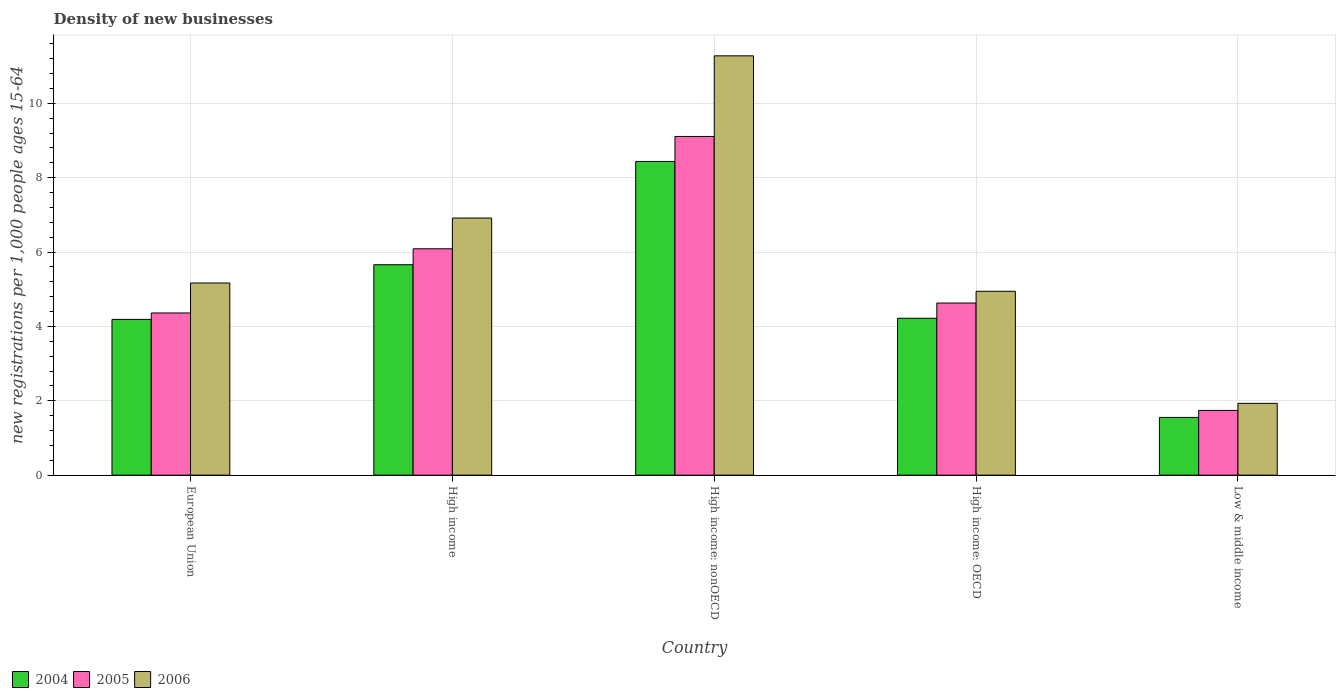How many different coloured bars are there?
Provide a succinct answer. 3. Are the number of bars per tick equal to the number of legend labels?
Provide a succinct answer. Yes. Are the number of bars on each tick of the X-axis equal?
Provide a succinct answer. Yes. How many bars are there on the 4th tick from the right?
Offer a terse response. 3. What is the label of the 5th group of bars from the left?
Ensure brevity in your answer.  Low & middle income. In how many cases, is the number of bars for a given country not equal to the number of legend labels?
Make the answer very short. 0. What is the number of new registrations in 2004 in European Union?
Keep it short and to the point. 4.19. Across all countries, what is the maximum number of new registrations in 2006?
Provide a short and direct response. 11.28. Across all countries, what is the minimum number of new registrations in 2005?
Provide a short and direct response. 1.74. In which country was the number of new registrations in 2004 maximum?
Your response must be concise. High income: nonOECD. In which country was the number of new registrations in 2005 minimum?
Offer a very short reply. Low & middle income. What is the total number of new registrations in 2004 in the graph?
Offer a terse response. 24.06. What is the difference between the number of new registrations in 2006 in High income: OECD and that in Low & middle income?
Provide a succinct answer. 3.01. What is the difference between the number of new registrations in 2006 in High income and the number of new registrations in 2005 in European Union?
Keep it short and to the point. 2.55. What is the average number of new registrations in 2006 per country?
Keep it short and to the point. 6.05. What is the difference between the number of new registrations of/in 2004 and number of new registrations of/in 2005 in European Union?
Your answer should be compact. -0.17. What is the ratio of the number of new registrations in 2004 in European Union to that in High income: OECD?
Give a very brief answer. 0.99. Is the number of new registrations in 2006 in High income: nonOECD less than that in Low & middle income?
Provide a succinct answer. No. Is the difference between the number of new registrations in 2004 in High income and High income: nonOECD greater than the difference between the number of new registrations in 2005 in High income and High income: nonOECD?
Make the answer very short. Yes. What is the difference between the highest and the second highest number of new registrations in 2006?
Make the answer very short. 6.11. What is the difference between the highest and the lowest number of new registrations in 2004?
Offer a very short reply. 6.88. In how many countries, is the number of new registrations in 2006 greater than the average number of new registrations in 2006 taken over all countries?
Provide a short and direct response. 2. Is the sum of the number of new registrations in 2006 in High income and High income: nonOECD greater than the maximum number of new registrations in 2005 across all countries?
Your answer should be compact. Yes. What does the 2nd bar from the left in High income: OECD represents?
Your answer should be very brief. 2005. Does the graph contain grids?
Your response must be concise. Yes. How many legend labels are there?
Offer a very short reply. 3. What is the title of the graph?
Provide a succinct answer. Density of new businesses. What is the label or title of the Y-axis?
Your answer should be very brief. New registrations per 1,0 people ages 15-64. What is the new registrations per 1,000 people ages 15-64 of 2004 in European Union?
Give a very brief answer. 4.19. What is the new registrations per 1,000 people ages 15-64 of 2005 in European Union?
Offer a very short reply. 4.36. What is the new registrations per 1,000 people ages 15-64 in 2006 in European Union?
Your response must be concise. 5.17. What is the new registrations per 1,000 people ages 15-64 in 2004 in High income?
Your response must be concise. 5.66. What is the new registrations per 1,000 people ages 15-64 in 2005 in High income?
Provide a short and direct response. 6.09. What is the new registrations per 1,000 people ages 15-64 in 2006 in High income?
Give a very brief answer. 6.91. What is the new registrations per 1,000 people ages 15-64 in 2004 in High income: nonOECD?
Your answer should be compact. 8.44. What is the new registrations per 1,000 people ages 15-64 of 2005 in High income: nonOECD?
Offer a terse response. 9.11. What is the new registrations per 1,000 people ages 15-64 in 2006 in High income: nonOECD?
Offer a very short reply. 11.28. What is the new registrations per 1,000 people ages 15-64 of 2004 in High income: OECD?
Your answer should be compact. 4.22. What is the new registrations per 1,000 people ages 15-64 in 2005 in High income: OECD?
Keep it short and to the point. 4.63. What is the new registrations per 1,000 people ages 15-64 in 2006 in High income: OECD?
Keep it short and to the point. 4.94. What is the new registrations per 1,000 people ages 15-64 of 2004 in Low & middle income?
Give a very brief answer. 1.55. What is the new registrations per 1,000 people ages 15-64 of 2005 in Low & middle income?
Give a very brief answer. 1.74. What is the new registrations per 1,000 people ages 15-64 of 2006 in Low & middle income?
Ensure brevity in your answer.  1.93. Across all countries, what is the maximum new registrations per 1,000 people ages 15-64 in 2004?
Your response must be concise. 8.44. Across all countries, what is the maximum new registrations per 1,000 people ages 15-64 in 2005?
Provide a succinct answer. 9.11. Across all countries, what is the maximum new registrations per 1,000 people ages 15-64 of 2006?
Give a very brief answer. 11.28. Across all countries, what is the minimum new registrations per 1,000 people ages 15-64 in 2004?
Provide a short and direct response. 1.55. Across all countries, what is the minimum new registrations per 1,000 people ages 15-64 of 2005?
Provide a succinct answer. 1.74. Across all countries, what is the minimum new registrations per 1,000 people ages 15-64 in 2006?
Make the answer very short. 1.93. What is the total new registrations per 1,000 people ages 15-64 of 2004 in the graph?
Your response must be concise. 24.06. What is the total new registrations per 1,000 people ages 15-64 in 2005 in the graph?
Give a very brief answer. 25.93. What is the total new registrations per 1,000 people ages 15-64 of 2006 in the graph?
Ensure brevity in your answer.  30.23. What is the difference between the new registrations per 1,000 people ages 15-64 of 2004 in European Union and that in High income?
Your answer should be compact. -1.47. What is the difference between the new registrations per 1,000 people ages 15-64 in 2005 in European Union and that in High income?
Make the answer very short. -1.73. What is the difference between the new registrations per 1,000 people ages 15-64 of 2006 in European Union and that in High income?
Give a very brief answer. -1.75. What is the difference between the new registrations per 1,000 people ages 15-64 of 2004 in European Union and that in High income: nonOECD?
Give a very brief answer. -4.25. What is the difference between the new registrations per 1,000 people ages 15-64 of 2005 in European Union and that in High income: nonOECD?
Ensure brevity in your answer.  -4.75. What is the difference between the new registrations per 1,000 people ages 15-64 in 2006 in European Union and that in High income: nonOECD?
Offer a very short reply. -6.11. What is the difference between the new registrations per 1,000 people ages 15-64 in 2004 in European Union and that in High income: OECD?
Keep it short and to the point. -0.03. What is the difference between the new registrations per 1,000 people ages 15-64 in 2005 in European Union and that in High income: OECD?
Your answer should be very brief. -0.27. What is the difference between the new registrations per 1,000 people ages 15-64 in 2006 in European Union and that in High income: OECD?
Your answer should be compact. 0.22. What is the difference between the new registrations per 1,000 people ages 15-64 of 2004 in European Union and that in Low & middle income?
Make the answer very short. 2.64. What is the difference between the new registrations per 1,000 people ages 15-64 in 2005 in European Union and that in Low & middle income?
Offer a very short reply. 2.62. What is the difference between the new registrations per 1,000 people ages 15-64 in 2006 in European Union and that in Low & middle income?
Offer a very short reply. 3.24. What is the difference between the new registrations per 1,000 people ages 15-64 in 2004 in High income and that in High income: nonOECD?
Offer a terse response. -2.78. What is the difference between the new registrations per 1,000 people ages 15-64 in 2005 in High income and that in High income: nonOECD?
Offer a very short reply. -3.02. What is the difference between the new registrations per 1,000 people ages 15-64 of 2006 in High income and that in High income: nonOECD?
Offer a terse response. -4.36. What is the difference between the new registrations per 1,000 people ages 15-64 of 2004 in High income and that in High income: OECD?
Provide a short and direct response. 1.44. What is the difference between the new registrations per 1,000 people ages 15-64 in 2005 in High income and that in High income: OECD?
Provide a succinct answer. 1.46. What is the difference between the new registrations per 1,000 people ages 15-64 in 2006 in High income and that in High income: OECD?
Offer a terse response. 1.97. What is the difference between the new registrations per 1,000 people ages 15-64 in 2004 in High income and that in Low & middle income?
Ensure brevity in your answer.  4.11. What is the difference between the new registrations per 1,000 people ages 15-64 of 2005 in High income and that in Low & middle income?
Your answer should be compact. 4.35. What is the difference between the new registrations per 1,000 people ages 15-64 in 2006 in High income and that in Low & middle income?
Give a very brief answer. 4.98. What is the difference between the new registrations per 1,000 people ages 15-64 of 2004 in High income: nonOECD and that in High income: OECD?
Your answer should be compact. 4.22. What is the difference between the new registrations per 1,000 people ages 15-64 in 2005 in High income: nonOECD and that in High income: OECD?
Offer a very short reply. 4.48. What is the difference between the new registrations per 1,000 people ages 15-64 in 2006 in High income: nonOECD and that in High income: OECD?
Your answer should be very brief. 6.33. What is the difference between the new registrations per 1,000 people ages 15-64 in 2004 in High income: nonOECD and that in Low & middle income?
Your response must be concise. 6.88. What is the difference between the new registrations per 1,000 people ages 15-64 in 2005 in High income: nonOECD and that in Low & middle income?
Your answer should be compact. 7.37. What is the difference between the new registrations per 1,000 people ages 15-64 of 2006 in High income: nonOECD and that in Low & middle income?
Provide a succinct answer. 9.34. What is the difference between the new registrations per 1,000 people ages 15-64 in 2004 in High income: OECD and that in Low & middle income?
Make the answer very short. 2.67. What is the difference between the new registrations per 1,000 people ages 15-64 of 2005 in High income: OECD and that in Low & middle income?
Provide a short and direct response. 2.89. What is the difference between the new registrations per 1,000 people ages 15-64 of 2006 in High income: OECD and that in Low & middle income?
Your answer should be very brief. 3.01. What is the difference between the new registrations per 1,000 people ages 15-64 in 2004 in European Union and the new registrations per 1,000 people ages 15-64 in 2005 in High income?
Your response must be concise. -1.9. What is the difference between the new registrations per 1,000 people ages 15-64 of 2004 in European Union and the new registrations per 1,000 people ages 15-64 of 2006 in High income?
Give a very brief answer. -2.73. What is the difference between the new registrations per 1,000 people ages 15-64 of 2005 in European Union and the new registrations per 1,000 people ages 15-64 of 2006 in High income?
Your answer should be very brief. -2.55. What is the difference between the new registrations per 1,000 people ages 15-64 of 2004 in European Union and the new registrations per 1,000 people ages 15-64 of 2005 in High income: nonOECD?
Provide a short and direct response. -4.92. What is the difference between the new registrations per 1,000 people ages 15-64 in 2004 in European Union and the new registrations per 1,000 people ages 15-64 in 2006 in High income: nonOECD?
Offer a very short reply. -7.09. What is the difference between the new registrations per 1,000 people ages 15-64 in 2005 in European Union and the new registrations per 1,000 people ages 15-64 in 2006 in High income: nonOECD?
Your response must be concise. -6.91. What is the difference between the new registrations per 1,000 people ages 15-64 in 2004 in European Union and the new registrations per 1,000 people ages 15-64 in 2005 in High income: OECD?
Provide a short and direct response. -0.44. What is the difference between the new registrations per 1,000 people ages 15-64 in 2004 in European Union and the new registrations per 1,000 people ages 15-64 in 2006 in High income: OECD?
Keep it short and to the point. -0.76. What is the difference between the new registrations per 1,000 people ages 15-64 in 2005 in European Union and the new registrations per 1,000 people ages 15-64 in 2006 in High income: OECD?
Provide a short and direct response. -0.58. What is the difference between the new registrations per 1,000 people ages 15-64 of 2004 in European Union and the new registrations per 1,000 people ages 15-64 of 2005 in Low & middle income?
Keep it short and to the point. 2.45. What is the difference between the new registrations per 1,000 people ages 15-64 of 2004 in European Union and the new registrations per 1,000 people ages 15-64 of 2006 in Low & middle income?
Offer a terse response. 2.26. What is the difference between the new registrations per 1,000 people ages 15-64 of 2005 in European Union and the new registrations per 1,000 people ages 15-64 of 2006 in Low & middle income?
Make the answer very short. 2.43. What is the difference between the new registrations per 1,000 people ages 15-64 of 2004 in High income and the new registrations per 1,000 people ages 15-64 of 2005 in High income: nonOECD?
Provide a short and direct response. -3.45. What is the difference between the new registrations per 1,000 people ages 15-64 in 2004 in High income and the new registrations per 1,000 people ages 15-64 in 2006 in High income: nonOECD?
Keep it short and to the point. -5.62. What is the difference between the new registrations per 1,000 people ages 15-64 of 2005 in High income and the new registrations per 1,000 people ages 15-64 of 2006 in High income: nonOECD?
Ensure brevity in your answer.  -5.19. What is the difference between the new registrations per 1,000 people ages 15-64 of 2004 in High income and the new registrations per 1,000 people ages 15-64 of 2005 in High income: OECD?
Provide a short and direct response. 1.03. What is the difference between the new registrations per 1,000 people ages 15-64 in 2004 in High income and the new registrations per 1,000 people ages 15-64 in 2006 in High income: OECD?
Your response must be concise. 0.71. What is the difference between the new registrations per 1,000 people ages 15-64 in 2005 in High income and the new registrations per 1,000 people ages 15-64 in 2006 in High income: OECD?
Provide a short and direct response. 1.14. What is the difference between the new registrations per 1,000 people ages 15-64 of 2004 in High income and the new registrations per 1,000 people ages 15-64 of 2005 in Low & middle income?
Your answer should be compact. 3.92. What is the difference between the new registrations per 1,000 people ages 15-64 of 2004 in High income and the new registrations per 1,000 people ages 15-64 of 2006 in Low & middle income?
Ensure brevity in your answer.  3.73. What is the difference between the new registrations per 1,000 people ages 15-64 in 2005 in High income and the new registrations per 1,000 people ages 15-64 in 2006 in Low & middle income?
Provide a short and direct response. 4.16. What is the difference between the new registrations per 1,000 people ages 15-64 of 2004 in High income: nonOECD and the new registrations per 1,000 people ages 15-64 of 2005 in High income: OECD?
Provide a short and direct response. 3.81. What is the difference between the new registrations per 1,000 people ages 15-64 of 2004 in High income: nonOECD and the new registrations per 1,000 people ages 15-64 of 2006 in High income: OECD?
Your answer should be compact. 3.49. What is the difference between the new registrations per 1,000 people ages 15-64 of 2005 in High income: nonOECD and the new registrations per 1,000 people ages 15-64 of 2006 in High income: OECD?
Your answer should be compact. 4.16. What is the difference between the new registrations per 1,000 people ages 15-64 of 2004 in High income: nonOECD and the new registrations per 1,000 people ages 15-64 of 2005 in Low & middle income?
Keep it short and to the point. 6.69. What is the difference between the new registrations per 1,000 people ages 15-64 in 2004 in High income: nonOECD and the new registrations per 1,000 people ages 15-64 in 2006 in Low & middle income?
Your response must be concise. 6.5. What is the difference between the new registrations per 1,000 people ages 15-64 in 2005 in High income: nonOECD and the new registrations per 1,000 people ages 15-64 in 2006 in Low & middle income?
Ensure brevity in your answer.  7.18. What is the difference between the new registrations per 1,000 people ages 15-64 of 2004 in High income: OECD and the new registrations per 1,000 people ages 15-64 of 2005 in Low & middle income?
Keep it short and to the point. 2.48. What is the difference between the new registrations per 1,000 people ages 15-64 in 2004 in High income: OECD and the new registrations per 1,000 people ages 15-64 in 2006 in Low & middle income?
Make the answer very short. 2.29. What is the difference between the new registrations per 1,000 people ages 15-64 of 2005 in High income: OECD and the new registrations per 1,000 people ages 15-64 of 2006 in Low & middle income?
Ensure brevity in your answer.  2.7. What is the average new registrations per 1,000 people ages 15-64 of 2004 per country?
Offer a terse response. 4.81. What is the average new registrations per 1,000 people ages 15-64 of 2005 per country?
Your answer should be very brief. 5.19. What is the average new registrations per 1,000 people ages 15-64 of 2006 per country?
Offer a terse response. 6.05. What is the difference between the new registrations per 1,000 people ages 15-64 of 2004 and new registrations per 1,000 people ages 15-64 of 2005 in European Union?
Make the answer very short. -0.17. What is the difference between the new registrations per 1,000 people ages 15-64 of 2004 and new registrations per 1,000 people ages 15-64 of 2006 in European Union?
Keep it short and to the point. -0.98. What is the difference between the new registrations per 1,000 people ages 15-64 of 2005 and new registrations per 1,000 people ages 15-64 of 2006 in European Union?
Provide a short and direct response. -0.81. What is the difference between the new registrations per 1,000 people ages 15-64 of 2004 and new registrations per 1,000 people ages 15-64 of 2005 in High income?
Provide a succinct answer. -0.43. What is the difference between the new registrations per 1,000 people ages 15-64 of 2004 and new registrations per 1,000 people ages 15-64 of 2006 in High income?
Provide a short and direct response. -1.26. What is the difference between the new registrations per 1,000 people ages 15-64 in 2005 and new registrations per 1,000 people ages 15-64 in 2006 in High income?
Offer a very short reply. -0.83. What is the difference between the new registrations per 1,000 people ages 15-64 in 2004 and new registrations per 1,000 people ages 15-64 in 2005 in High income: nonOECD?
Offer a very short reply. -0.67. What is the difference between the new registrations per 1,000 people ages 15-64 of 2004 and new registrations per 1,000 people ages 15-64 of 2006 in High income: nonOECD?
Your answer should be very brief. -2.84. What is the difference between the new registrations per 1,000 people ages 15-64 of 2005 and new registrations per 1,000 people ages 15-64 of 2006 in High income: nonOECD?
Ensure brevity in your answer.  -2.17. What is the difference between the new registrations per 1,000 people ages 15-64 of 2004 and new registrations per 1,000 people ages 15-64 of 2005 in High income: OECD?
Provide a succinct answer. -0.41. What is the difference between the new registrations per 1,000 people ages 15-64 of 2004 and new registrations per 1,000 people ages 15-64 of 2006 in High income: OECD?
Keep it short and to the point. -0.73. What is the difference between the new registrations per 1,000 people ages 15-64 in 2005 and new registrations per 1,000 people ages 15-64 in 2006 in High income: OECD?
Provide a short and direct response. -0.32. What is the difference between the new registrations per 1,000 people ages 15-64 of 2004 and new registrations per 1,000 people ages 15-64 of 2005 in Low & middle income?
Give a very brief answer. -0.19. What is the difference between the new registrations per 1,000 people ages 15-64 of 2004 and new registrations per 1,000 people ages 15-64 of 2006 in Low & middle income?
Your response must be concise. -0.38. What is the difference between the new registrations per 1,000 people ages 15-64 of 2005 and new registrations per 1,000 people ages 15-64 of 2006 in Low & middle income?
Keep it short and to the point. -0.19. What is the ratio of the new registrations per 1,000 people ages 15-64 in 2004 in European Union to that in High income?
Give a very brief answer. 0.74. What is the ratio of the new registrations per 1,000 people ages 15-64 of 2005 in European Union to that in High income?
Ensure brevity in your answer.  0.72. What is the ratio of the new registrations per 1,000 people ages 15-64 of 2006 in European Union to that in High income?
Offer a very short reply. 0.75. What is the ratio of the new registrations per 1,000 people ages 15-64 of 2004 in European Union to that in High income: nonOECD?
Make the answer very short. 0.5. What is the ratio of the new registrations per 1,000 people ages 15-64 in 2005 in European Union to that in High income: nonOECD?
Your answer should be very brief. 0.48. What is the ratio of the new registrations per 1,000 people ages 15-64 in 2006 in European Union to that in High income: nonOECD?
Ensure brevity in your answer.  0.46. What is the ratio of the new registrations per 1,000 people ages 15-64 of 2005 in European Union to that in High income: OECD?
Your answer should be very brief. 0.94. What is the ratio of the new registrations per 1,000 people ages 15-64 of 2006 in European Union to that in High income: OECD?
Your answer should be compact. 1.04. What is the ratio of the new registrations per 1,000 people ages 15-64 in 2004 in European Union to that in Low & middle income?
Provide a succinct answer. 2.7. What is the ratio of the new registrations per 1,000 people ages 15-64 of 2005 in European Union to that in Low & middle income?
Provide a succinct answer. 2.51. What is the ratio of the new registrations per 1,000 people ages 15-64 of 2006 in European Union to that in Low & middle income?
Keep it short and to the point. 2.68. What is the ratio of the new registrations per 1,000 people ages 15-64 in 2004 in High income to that in High income: nonOECD?
Ensure brevity in your answer.  0.67. What is the ratio of the new registrations per 1,000 people ages 15-64 in 2005 in High income to that in High income: nonOECD?
Your answer should be very brief. 0.67. What is the ratio of the new registrations per 1,000 people ages 15-64 in 2006 in High income to that in High income: nonOECD?
Your answer should be very brief. 0.61. What is the ratio of the new registrations per 1,000 people ages 15-64 in 2004 in High income to that in High income: OECD?
Offer a very short reply. 1.34. What is the ratio of the new registrations per 1,000 people ages 15-64 in 2005 in High income to that in High income: OECD?
Provide a succinct answer. 1.31. What is the ratio of the new registrations per 1,000 people ages 15-64 in 2006 in High income to that in High income: OECD?
Make the answer very short. 1.4. What is the ratio of the new registrations per 1,000 people ages 15-64 of 2004 in High income to that in Low & middle income?
Ensure brevity in your answer.  3.64. What is the ratio of the new registrations per 1,000 people ages 15-64 of 2005 in High income to that in Low & middle income?
Keep it short and to the point. 3.5. What is the ratio of the new registrations per 1,000 people ages 15-64 of 2006 in High income to that in Low & middle income?
Offer a very short reply. 3.58. What is the ratio of the new registrations per 1,000 people ages 15-64 of 2004 in High income: nonOECD to that in High income: OECD?
Offer a terse response. 2. What is the ratio of the new registrations per 1,000 people ages 15-64 in 2005 in High income: nonOECD to that in High income: OECD?
Keep it short and to the point. 1.97. What is the ratio of the new registrations per 1,000 people ages 15-64 of 2006 in High income: nonOECD to that in High income: OECD?
Ensure brevity in your answer.  2.28. What is the ratio of the new registrations per 1,000 people ages 15-64 in 2004 in High income: nonOECD to that in Low & middle income?
Make the answer very short. 5.43. What is the ratio of the new registrations per 1,000 people ages 15-64 of 2005 in High income: nonOECD to that in Low & middle income?
Offer a very short reply. 5.23. What is the ratio of the new registrations per 1,000 people ages 15-64 of 2006 in High income: nonOECD to that in Low & middle income?
Give a very brief answer. 5.84. What is the ratio of the new registrations per 1,000 people ages 15-64 in 2004 in High income: OECD to that in Low & middle income?
Your answer should be compact. 2.72. What is the ratio of the new registrations per 1,000 people ages 15-64 in 2005 in High income: OECD to that in Low & middle income?
Provide a succinct answer. 2.66. What is the ratio of the new registrations per 1,000 people ages 15-64 of 2006 in High income: OECD to that in Low & middle income?
Offer a very short reply. 2.56. What is the difference between the highest and the second highest new registrations per 1,000 people ages 15-64 of 2004?
Offer a terse response. 2.78. What is the difference between the highest and the second highest new registrations per 1,000 people ages 15-64 of 2005?
Offer a very short reply. 3.02. What is the difference between the highest and the second highest new registrations per 1,000 people ages 15-64 of 2006?
Make the answer very short. 4.36. What is the difference between the highest and the lowest new registrations per 1,000 people ages 15-64 in 2004?
Make the answer very short. 6.88. What is the difference between the highest and the lowest new registrations per 1,000 people ages 15-64 of 2005?
Your response must be concise. 7.37. What is the difference between the highest and the lowest new registrations per 1,000 people ages 15-64 in 2006?
Your answer should be compact. 9.34. 